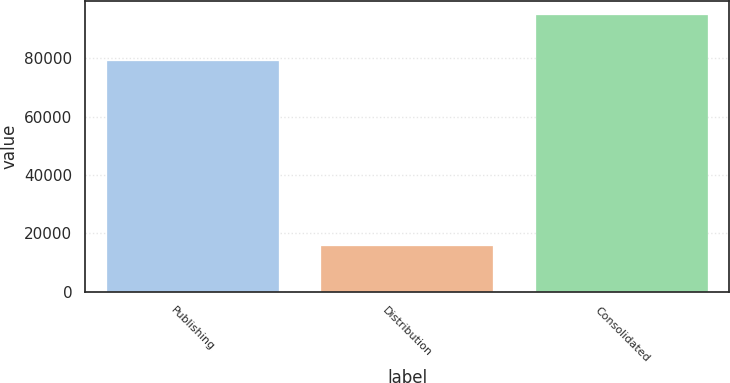Convert chart to OTSL. <chart><loc_0><loc_0><loc_500><loc_500><bar_chart><fcel>Publishing<fcel>Distribution<fcel>Consolidated<nl><fcel>79139<fcel>15708<fcel>94847<nl></chart> 